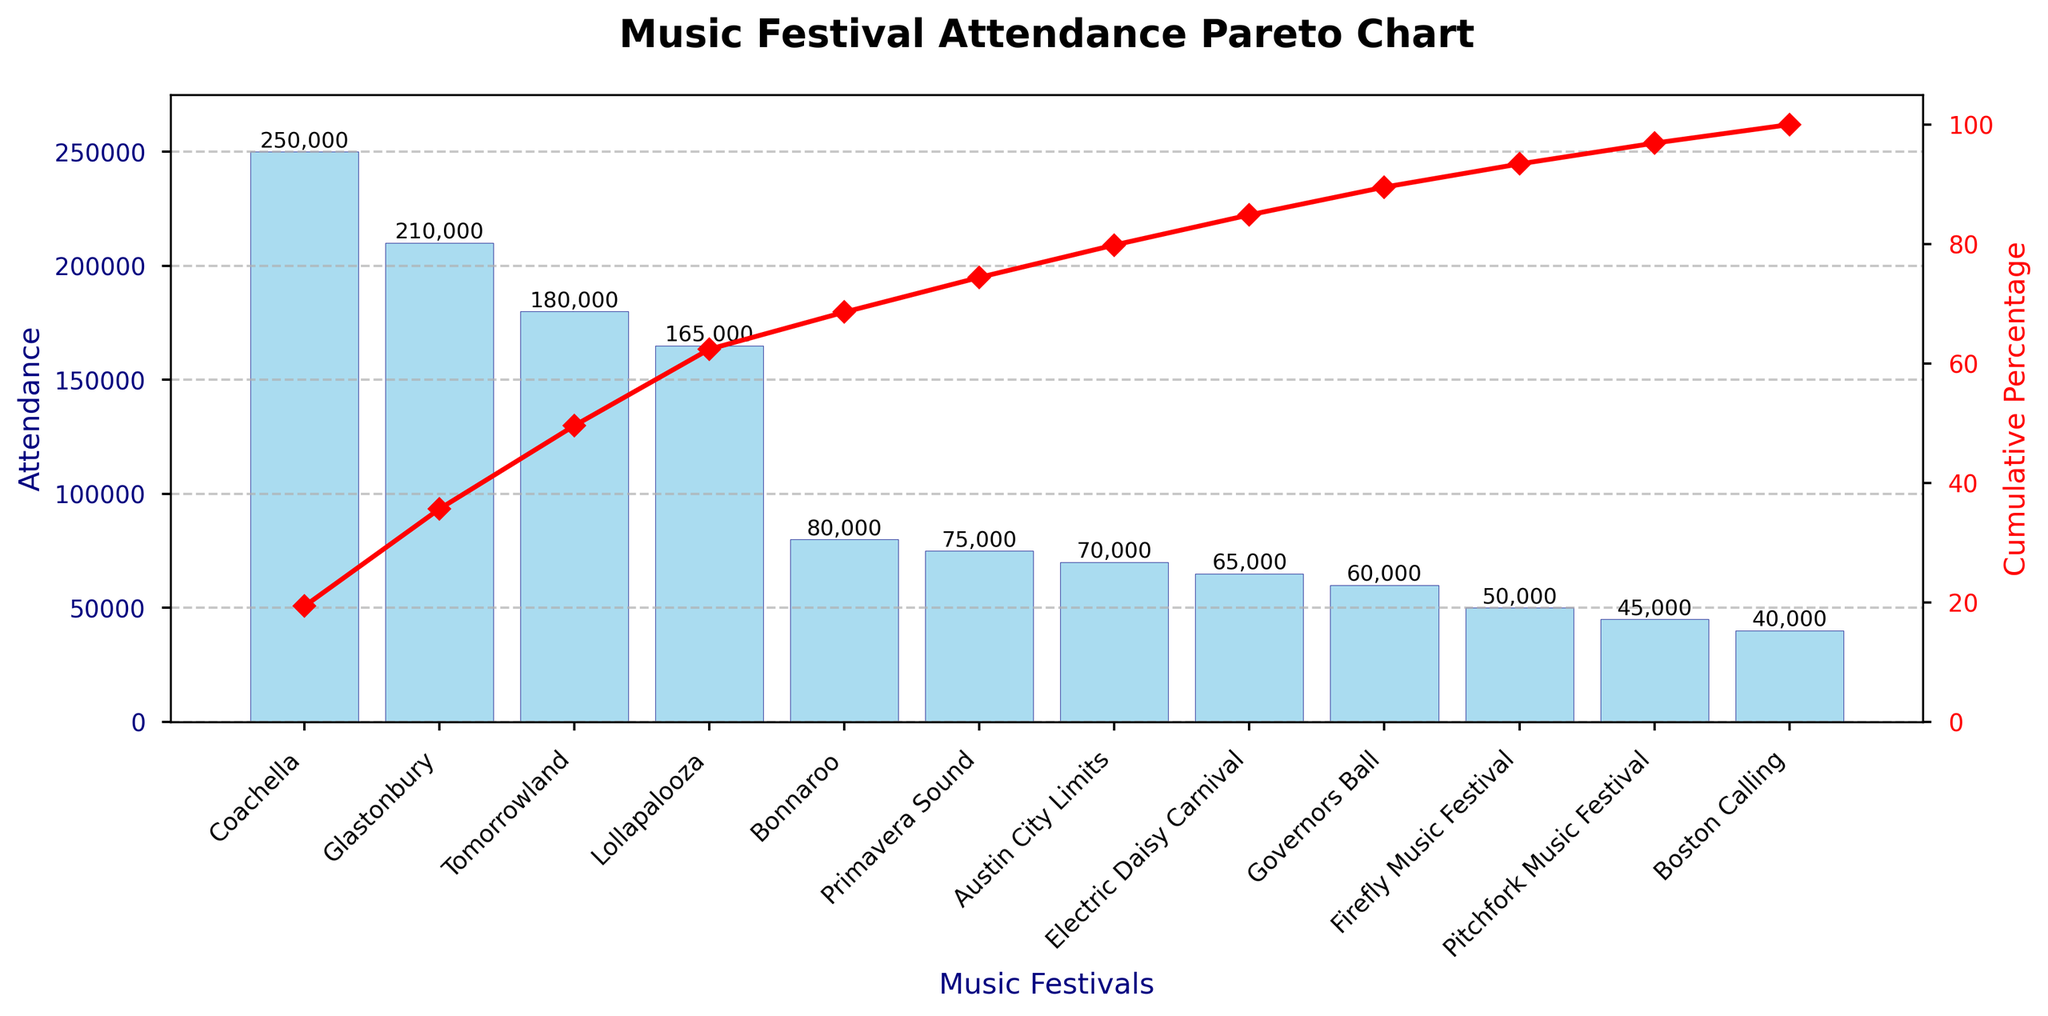What is the title of the chart? The title of the chart is usually located at the top. In this case, it reads "Music Festival Attendance Pareto Chart".
Answer: Music Festival Attendance Pareto Chart How many music festivals are represented in the chart? By counting the number of bars or festival names listed in the x-axis labels, we can determine the total number of music festivals.
Answer: 12 Which music festival has the highest attendance? The highest bar represents the festival with the highest attendance. The label at the top of this bar shows "Coachella".
Answer: Coachella What is the cumulative percentage of attendance after the top three festivals? To find this, look at the cumulative percentage line (red line) at the third festival on the x-axis. The point where the line crosses the label for the third festival, "Tomorrowland", shows the cumulative percentage.
Answer: Approximately 58% What is the attendance difference between Coachella and Bonnaroo? Locate the bars for Coachella and Bonnaroo and subtract the attendance number of Bonnaroo from Coachella. Coachella has 250,000 and Bonnaroo has 80,000.
Answer: 170,000 Which festival marks the point where cumulative attendance first exceeds 50% of the total? Follow the cumulative percentage line (red line) until it first crosses the 50% mark. The corresponding festival label on the x-axis below this point is "Tomorrowland".
Answer: Tomorrowland Is the cumulative percentage line always increasing? Since the cumulative nature of the line means it sums attendance figures progressively, it should always increase or stay constant. By visually inspecting the line, we can confirm it does not decrease.
Answer: Yes Which has a higher attendance: Boston Calling or Firefly Music Festival? Compare the heights of the bars corresponding to "Boston Calling" and "Firefly Music Festival". The taller bar corresponds to "Firefly Music Festival".
Answer: Firefly Music Festival How many festivals have an attendance over 100,000? Count the number of bars extending above the 100,000 mark on the y-axis. The festivals here are Coachella, Glastonbury, Tomorrowland, and Lollapalooza.
Answer: 4 What percentage of the total attendance is contributed by the lowest-attending festival? To find this, take the attendance of the lowest bar, "Boston Calling" (40,000), and divide it by the total attendance, then multiply by 100. The total attendance can be summed up from the data points. Total is 1,300,000.
Answer: Approximately 3.08% 